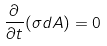<formula> <loc_0><loc_0><loc_500><loc_500>\frac { \partial } { \partial t } ( \sigma d A ) = 0</formula> 